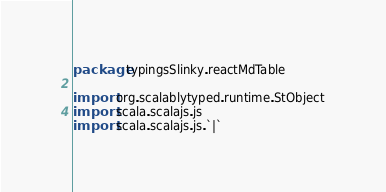<code> <loc_0><loc_0><loc_500><loc_500><_Scala_>package typingsSlinky.reactMdTable

import org.scalablytyped.runtime.StObject
import scala.scalajs.js
import scala.scalajs.js.`|`</code> 